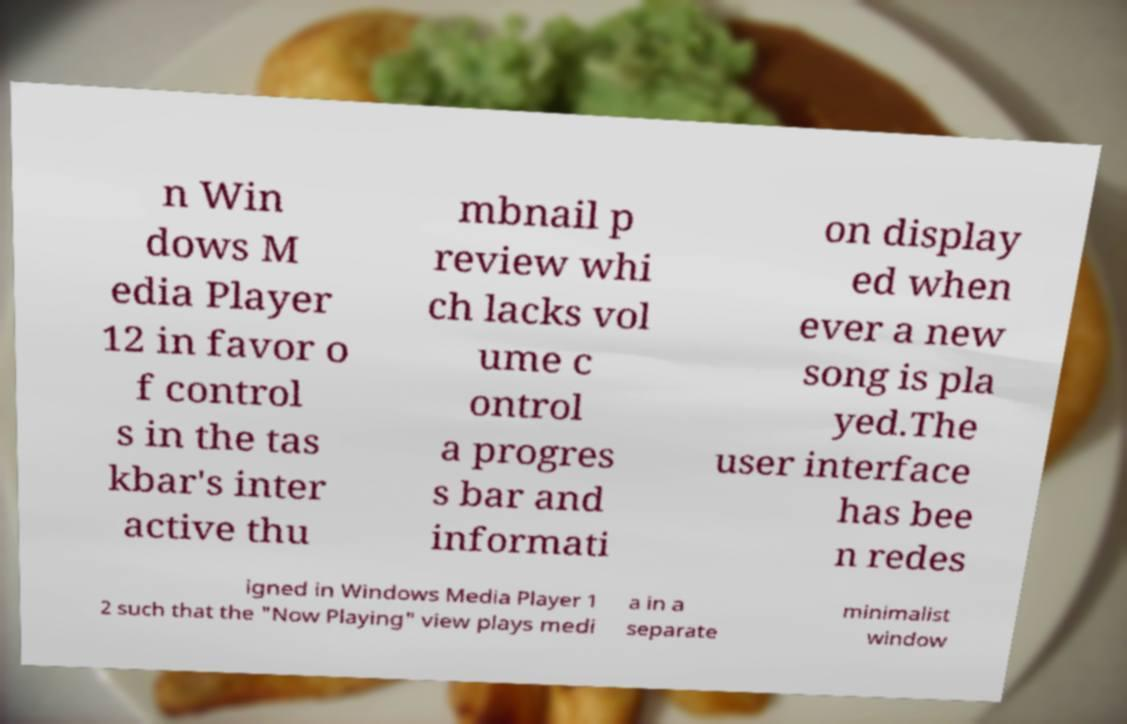Please read and relay the text visible in this image. What does it say? n Win dows M edia Player 12 in favor o f control s in the tas kbar's inter active thu mbnail p review whi ch lacks vol ume c ontrol a progres s bar and informati on display ed when ever a new song is pla yed.The user interface has bee n redes igned in Windows Media Player 1 2 such that the "Now Playing" view plays medi a in a separate minimalist window 